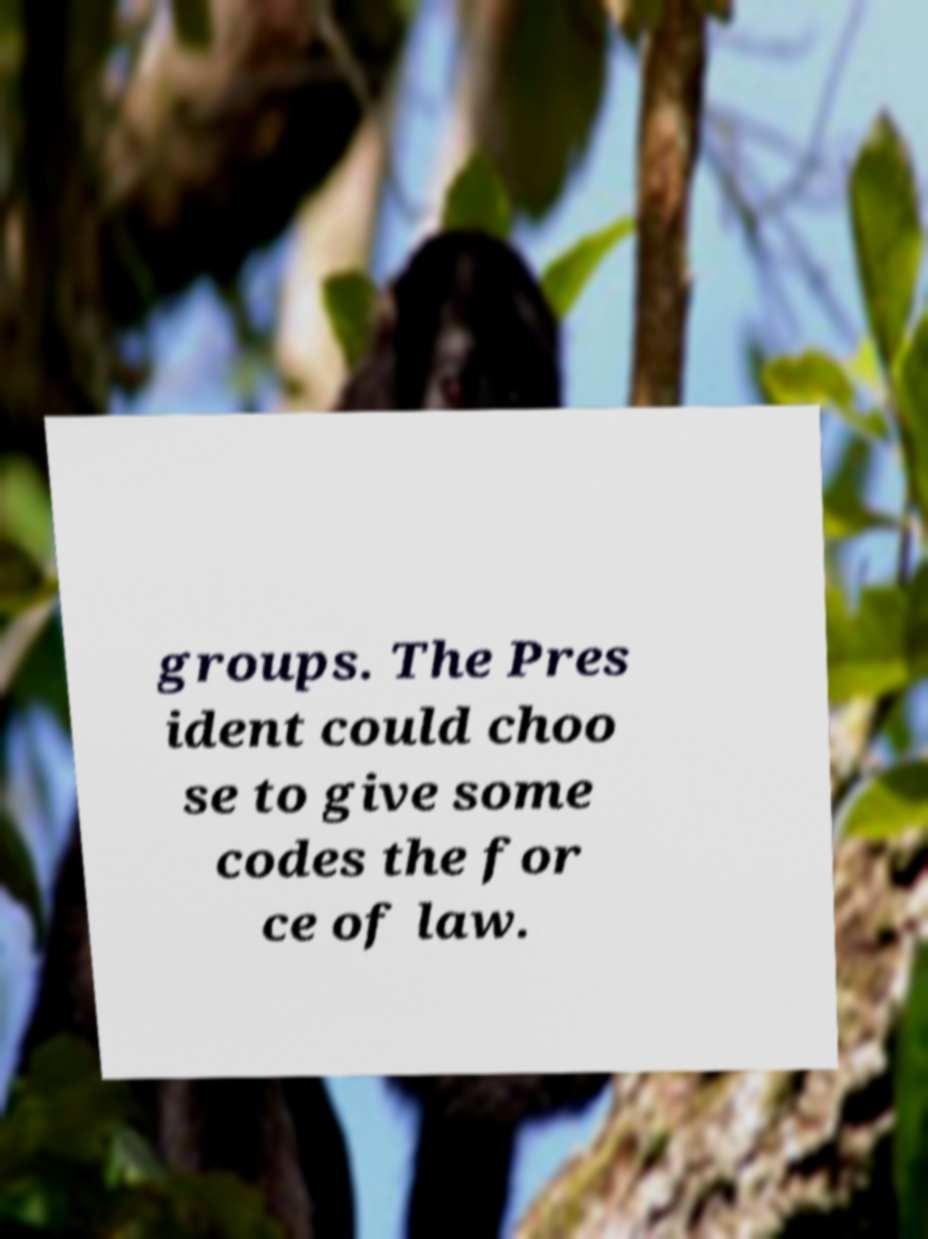For documentation purposes, I need the text within this image transcribed. Could you provide that? groups. The Pres ident could choo se to give some codes the for ce of law. 